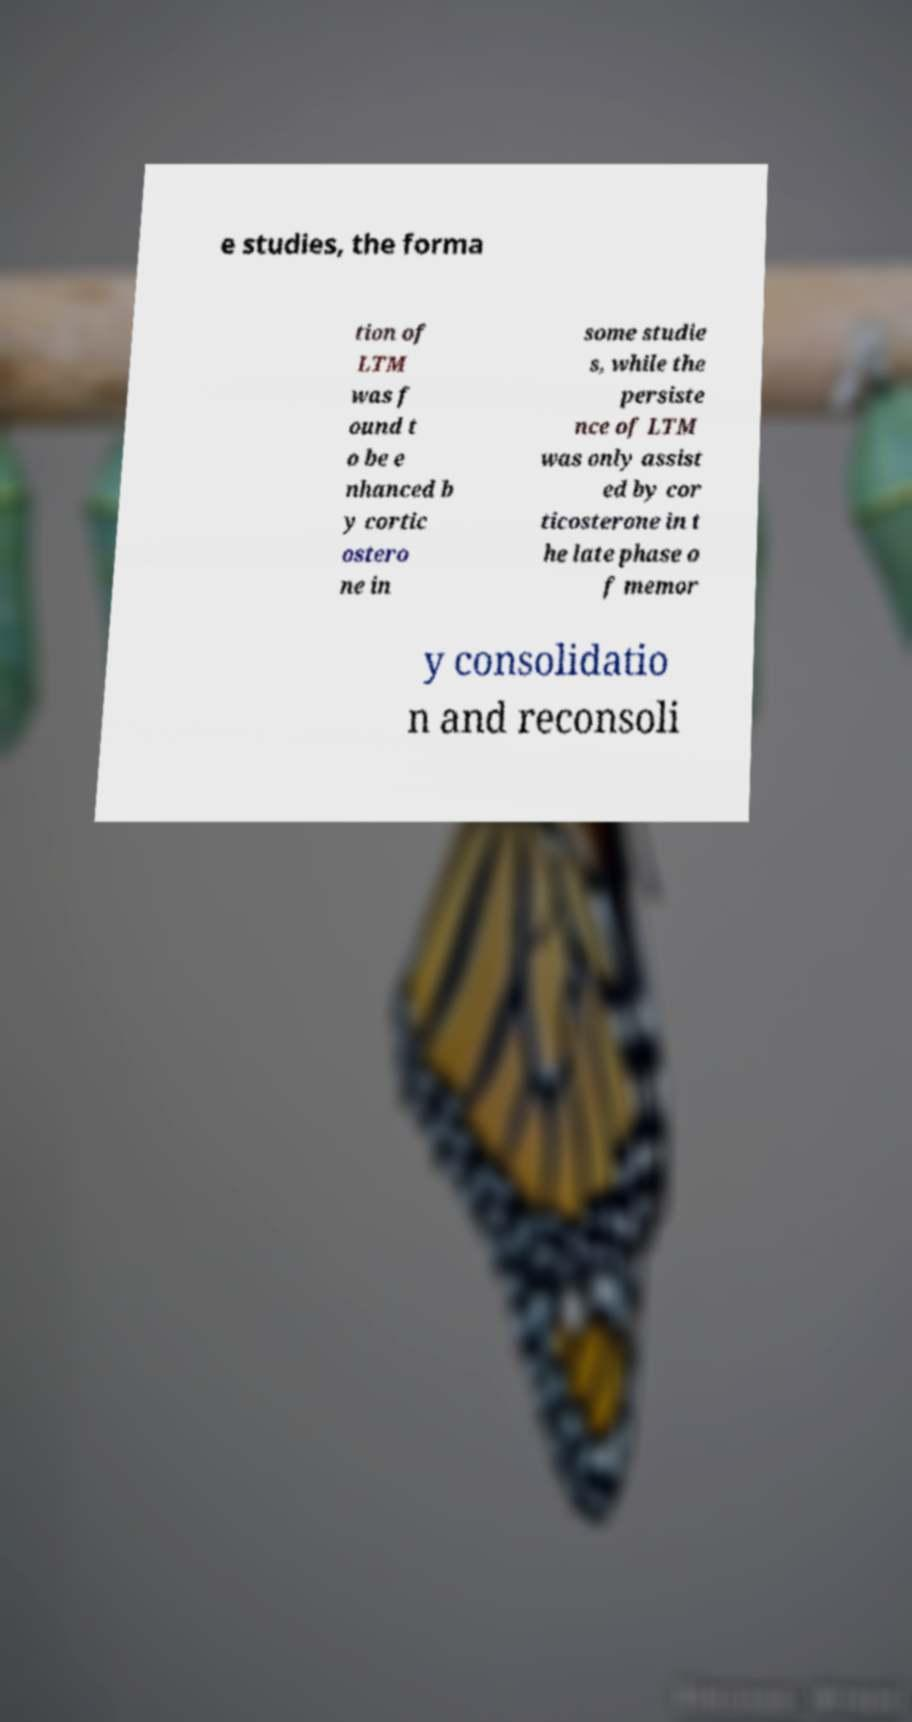Can you read and provide the text displayed in the image?This photo seems to have some interesting text. Can you extract and type it out for me? e studies, the forma tion of LTM was f ound t o be e nhanced b y cortic ostero ne in some studie s, while the persiste nce of LTM was only assist ed by cor ticosterone in t he late phase o f memor y consolidatio n and reconsoli 